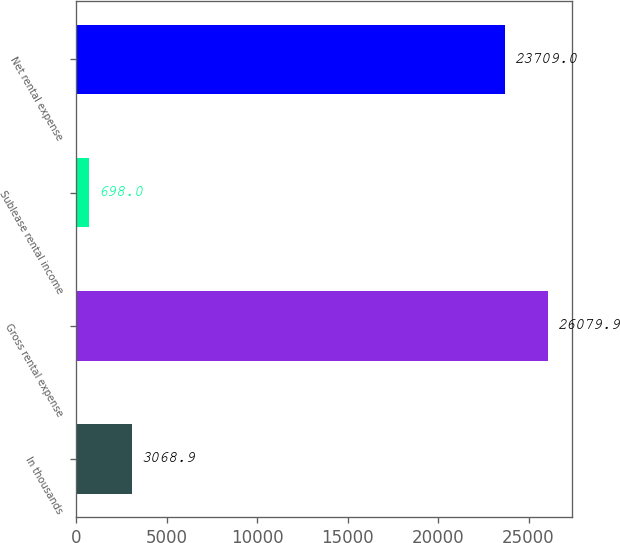Convert chart. <chart><loc_0><loc_0><loc_500><loc_500><bar_chart><fcel>In thousands<fcel>Gross rental expense<fcel>Sublease rental income<fcel>Net rental expense<nl><fcel>3068.9<fcel>26079.9<fcel>698<fcel>23709<nl></chart> 